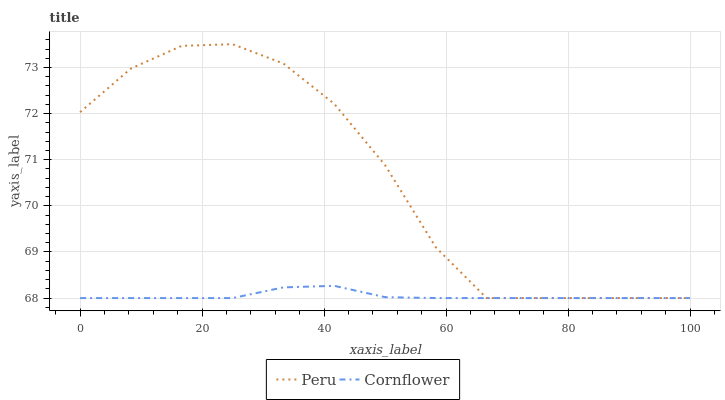Does Cornflower have the minimum area under the curve?
Answer yes or no. Yes. Does Peru have the maximum area under the curve?
Answer yes or no. Yes. Does Peru have the minimum area under the curve?
Answer yes or no. No. Is Cornflower the smoothest?
Answer yes or no. Yes. Is Peru the roughest?
Answer yes or no. Yes. Is Peru the smoothest?
Answer yes or no. No. Does Cornflower have the lowest value?
Answer yes or no. Yes. Does Peru have the highest value?
Answer yes or no. Yes. Does Peru intersect Cornflower?
Answer yes or no. Yes. Is Peru less than Cornflower?
Answer yes or no. No. Is Peru greater than Cornflower?
Answer yes or no. No. 